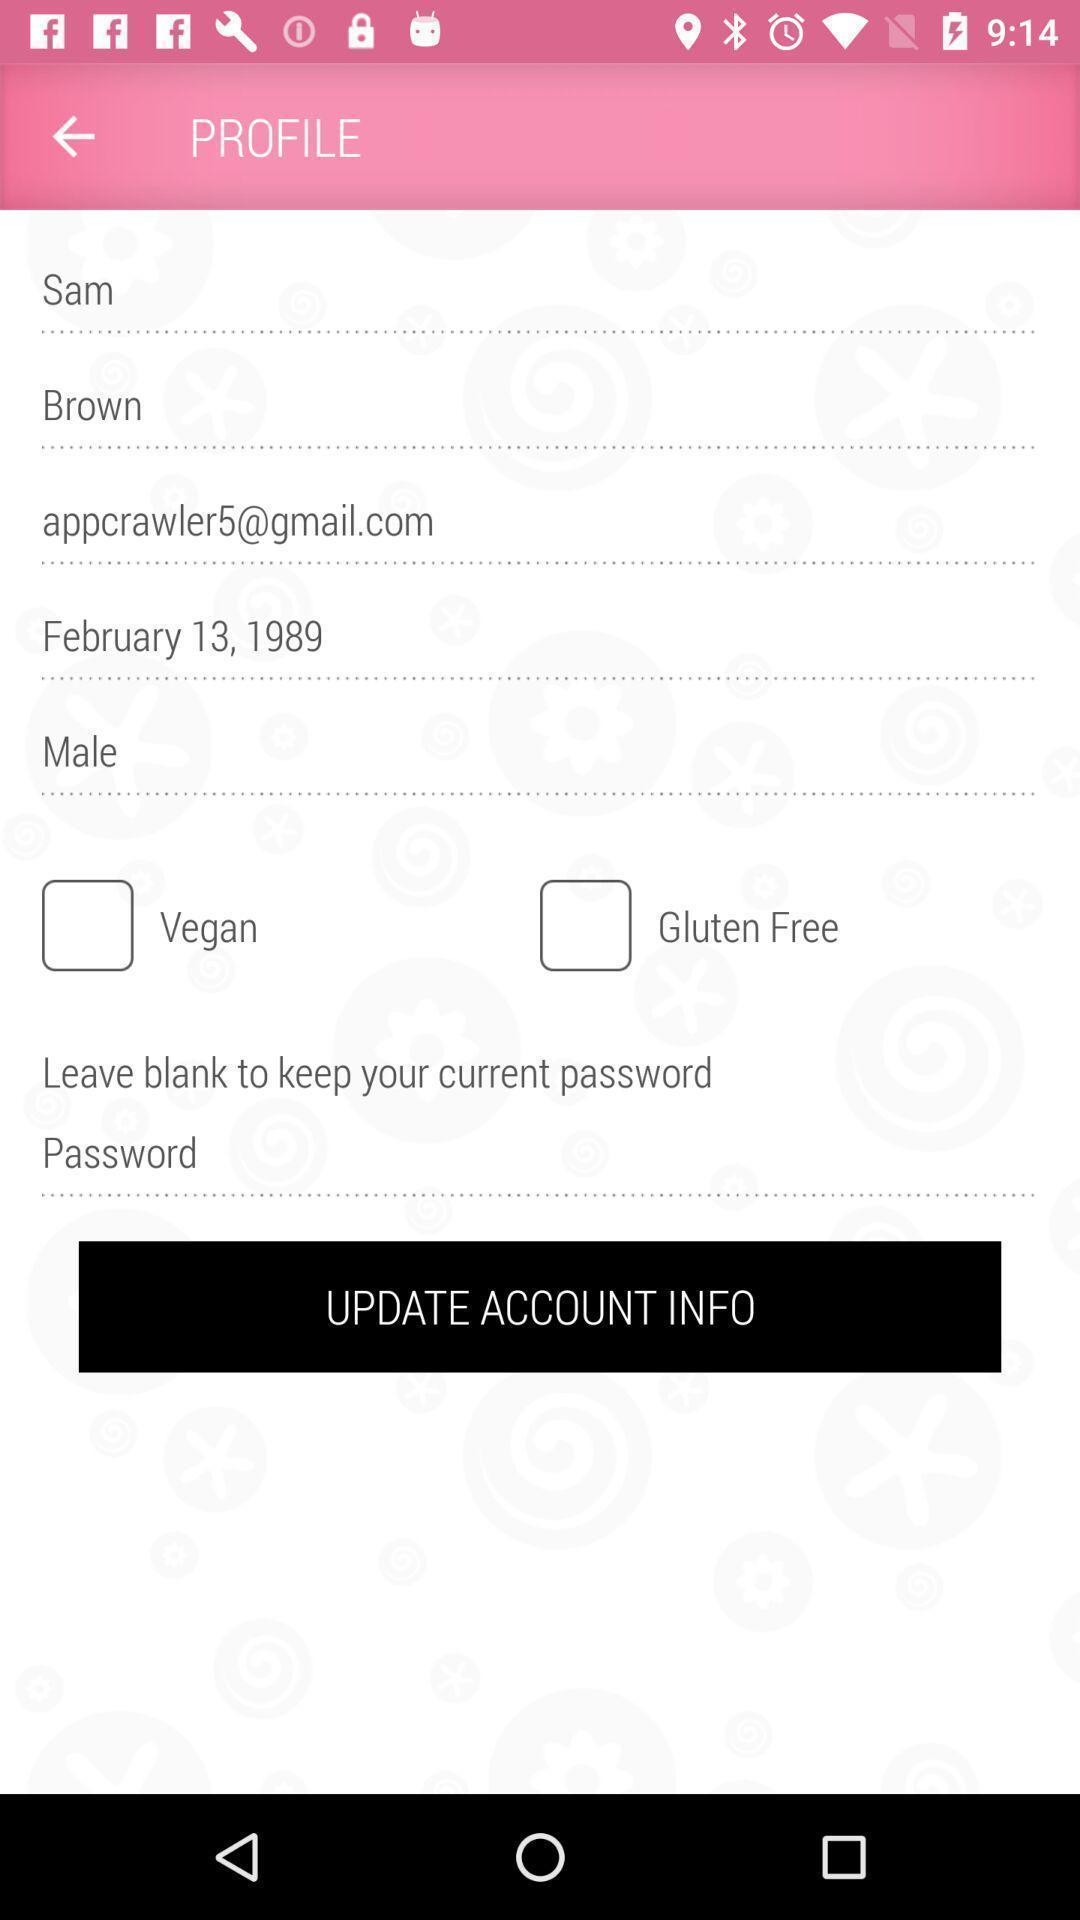Provide a detailed account of this screenshot. Update account information in a profile. 